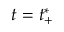Convert formula to latex. <formula><loc_0><loc_0><loc_500><loc_500>t = t _ { + } ^ { * }</formula> 